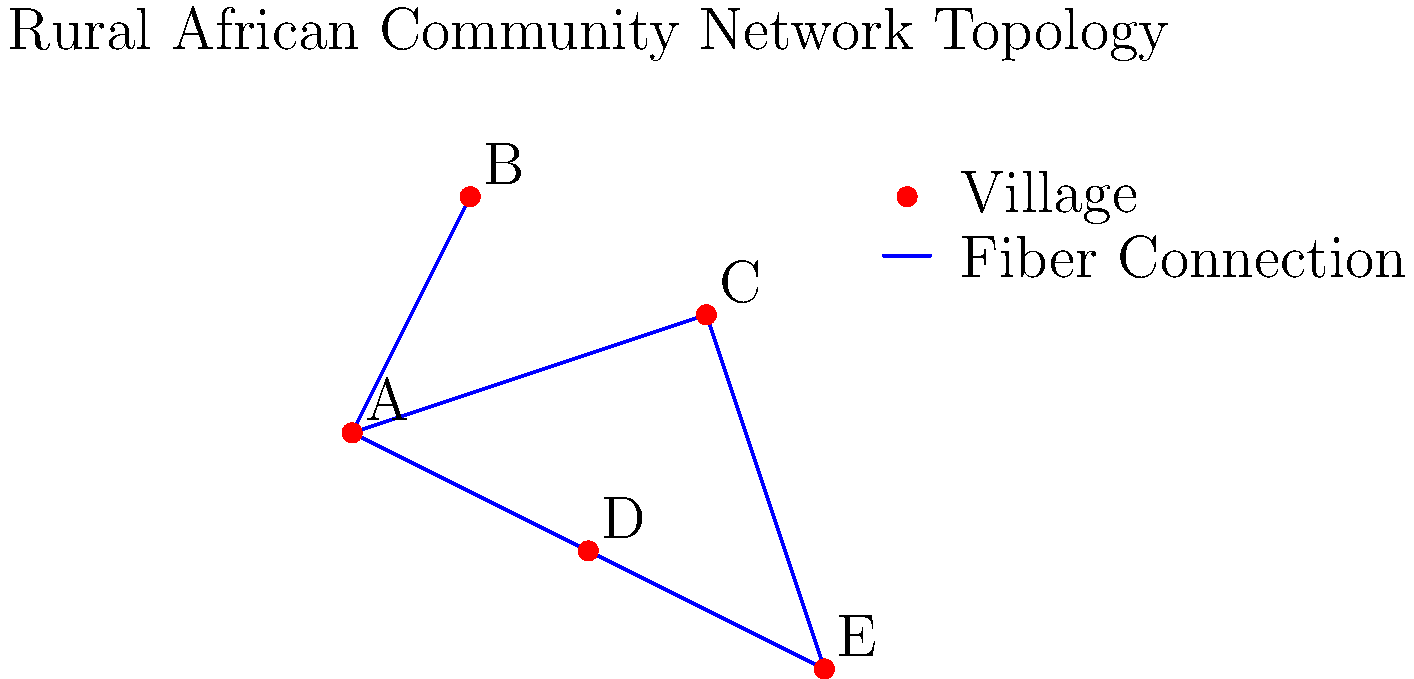Given the network topology for a rural African community shown above, which village would be the most suitable location for the main internet gateway to minimize the number of hops for all other villages? To determine the most suitable location for the main internet gateway, we need to analyze the network topology and calculate the number of hops required for each village to reach all other villages. The village with the lowest total number of hops to all other villages would be the most efficient location for the gateway.

Let's calculate the number of hops from each village to all others:

1. Village A:
   - To B: 1 hop
   - To C: 1 hop
   - To D: 1 hop
   - To E: 2 hops (via C or D)
   Total: 5 hops

2. Village B:
   - To A: 1 hop
   - To C: 2 hops (via A)
   - To D: 2 hops (via A)
   - To E: 3 hops (via A and C or D)
   Total: 8 hops

3. Village C:
   - To A: 1 hop
   - To B: 2 hops (via A)
   - To D: 2 hops (via A)
   - To E: 1 hop
   Total: 6 hops

4. Village D:
   - To A: 1 hop
   - To B: 2 hops (via A)
   - To C: 2 hops (via A)
   - To E: 1 hop
   Total: 6 hops

5. Village E:
   - To A: 2 hops (via C or D)
   - To B: 3 hops (via C or D and A)
   - To C: 1 hop
   - To D: 1 hop
   Total: 7 hops

Village A has the lowest total number of hops (5) to reach all other villages, making it the most suitable location for the main internet gateway.
Answer: Village A 